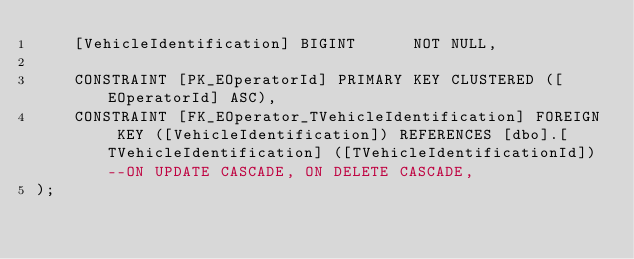<code> <loc_0><loc_0><loc_500><loc_500><_SQL_>	[VehicleIdentification]	BIGINT		NOT NULL,

	CONSTRAINT [PK_EOperatorId] PRIMARY KEY CLUSTERED ([EOperatorId] ASC),
	CONSTRAINT [FK_EOperator_TVehicleIdentification] FOREIGN KEY ([VehicleIdentification]) REFERENCES [dbo].[TVehicleIdentification] ([TVehicleIdentificationId]) --ON UPDATE CASCADE, ON DELETE CASCADE,
);
</code> 